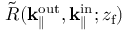Convert formula to latex. <formula><loc_0><loc_0><loc_500><loc_500>\tilde { R } ( { k _ { \| } ^ { o u t } } , k _ { \| } ^ { i n } ; { z _ { f } } )</formula> 